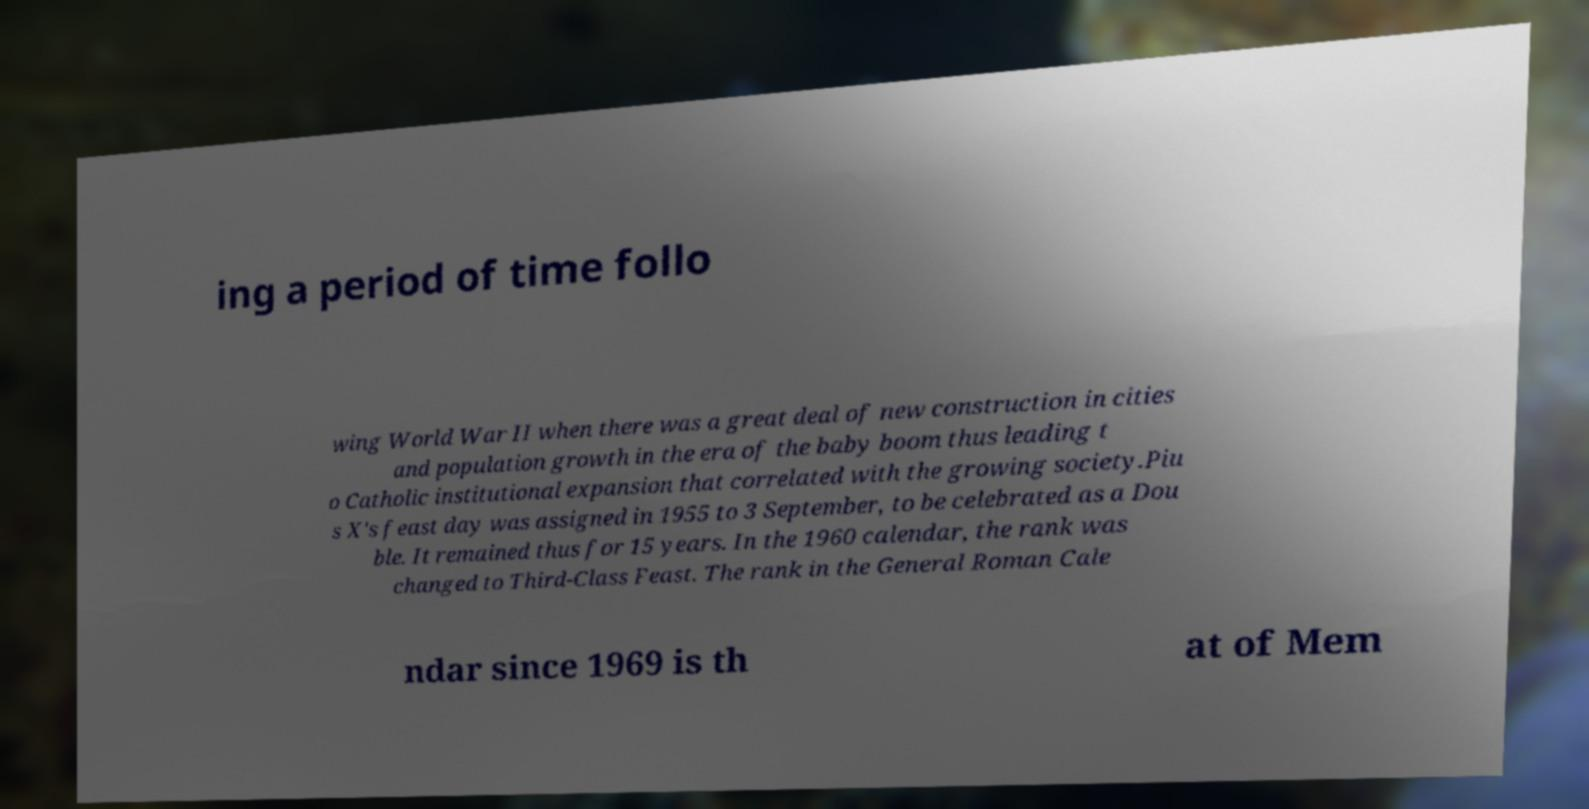Please identify and transcribe the text found in this image. ing a period of time follo wing World War II when there was a great deal of new construction in cities and population growth in the era of the baby boom thus leading t o Catholic institutional expansion that correlated with the growing society.Piu s X's feast day was assigned in 1955 to 3 September, to be celebrated as a Dou ble. It remained thus for 15 years. In the 1960 calendar, the rank was changed to Third-Class Feast. The rank in the General Roman Cale ndar since 1969 is th at of Mem 